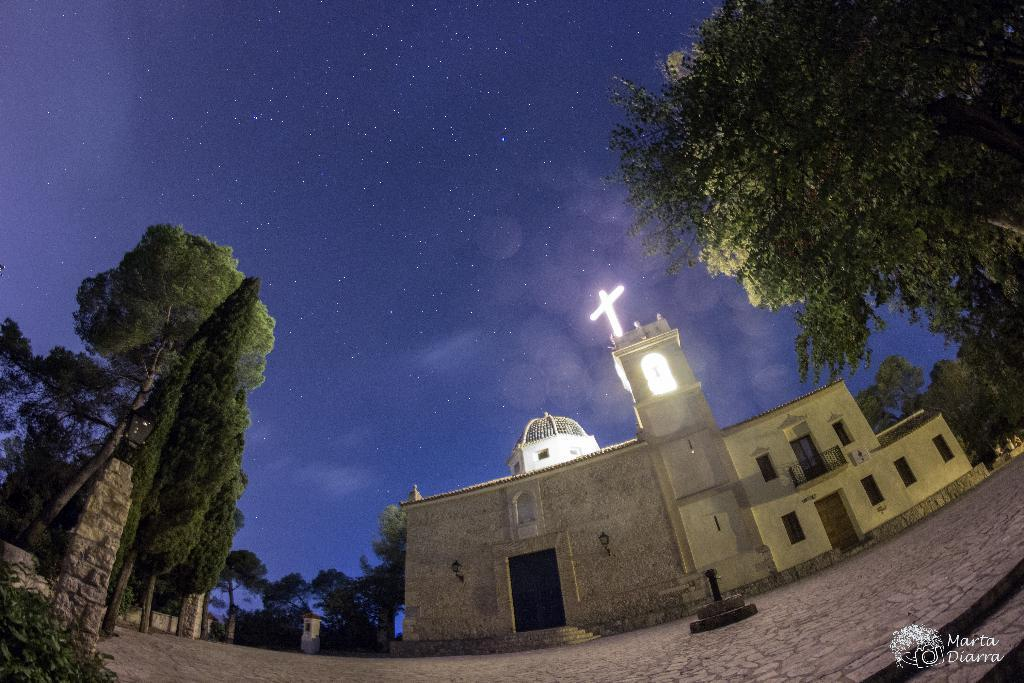What type of structure is visible in the image? There is a building in the image. What are some features of the building? The building has walls, doors, windows, and railings. What other elements can be seen in the image? There are trees, plants, lights, and a holy cross visible in the image. What is visible in the background of the image? The sky is visible in the background of the image. What organization is responsible for maintaining the air quality in the image? There is no information about air quality or any organization in the image. How does the rub from the building affect the surrounding environment in the image? There is no mention of rub or any environmental impact in the image. 